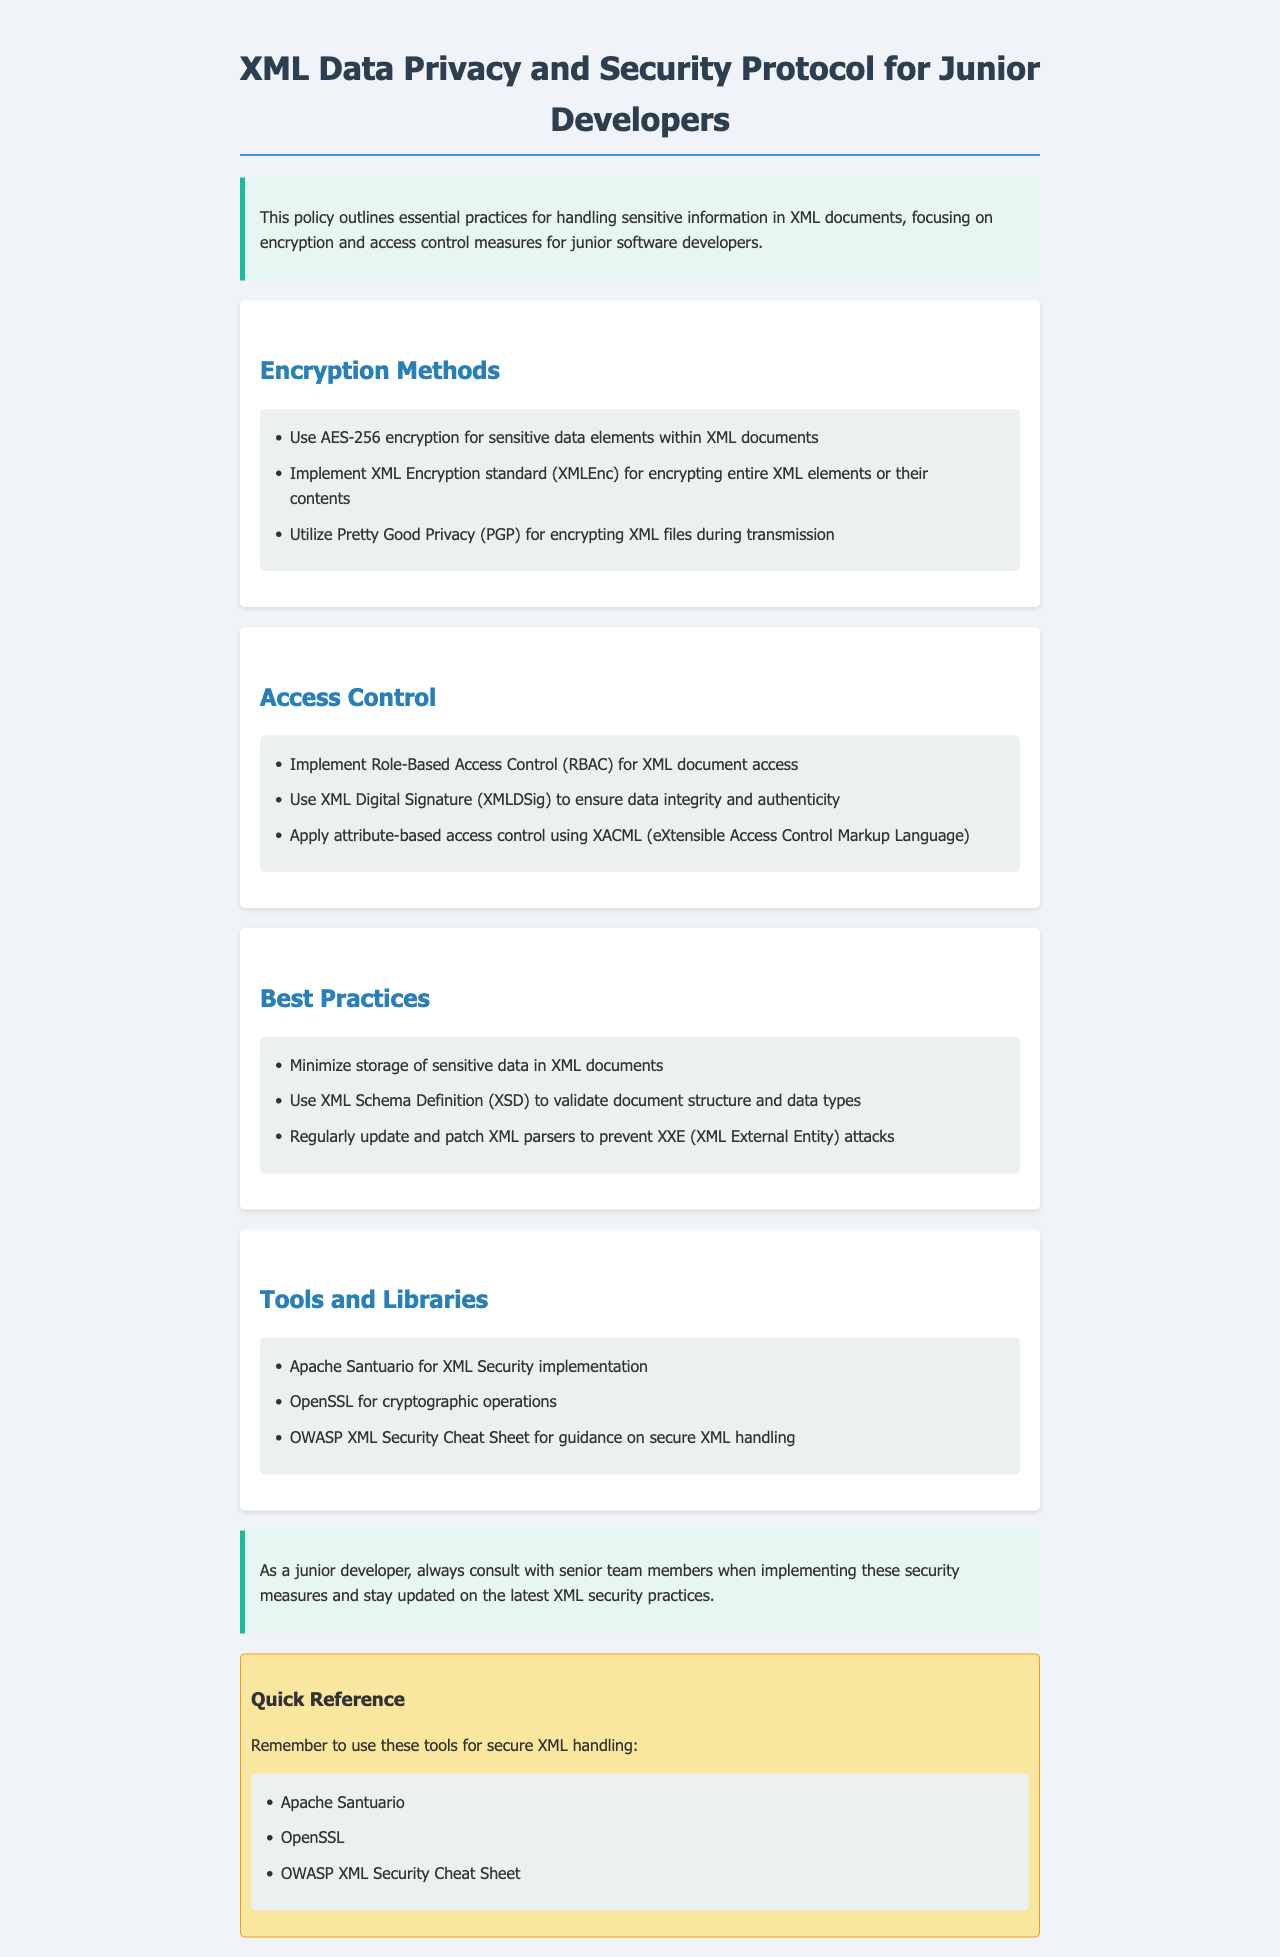What are the encryption methods mentioned? The document lists several encryption methods including AES-256, XML Encryption standard, and PGP.
Answer: AES-256, XML Encryption standard, PGP What does RBAC stand for in the context of access control? In the document, RBAC refers to Role-Based Access Control concerning XML document access.
Answer: Role-Based Access Control Which standard is used for encrypting entire XML elements? The document specifies the XML Encryption standard (XMLEnc) as the method for encrypting entire XML elements.
Answer: XML Encryption standard What should you do to ensure data integrity and authenticity? The document mentions the use of XML Digital Signature (XMLDSig) to ensure data integrity and authenticity.
Answer: XML Digital Signature How many tools are suggested for secure XML handling? The document lists three tools specifically aimed at secure XML handling.
Answer: Three What is the primary focus of this policy? The policy aims to outline practices for handling sensitive information, specifically regarding encryption and access control.
Answer: Encryption and access control Which library is recommended for cryptographic operations? The document includes OpenSSL as a recommended library for performing cryptographic operations.
Answer: OpenSSL What practice minimizes storage of sensitive data in XML documents? The document advises minimizing the storage of sensitive data as a best practice.
Answer: Minimize storage What is the significance of XML Schema Definition (XSD)? The document states XSD is used to validate document structure and data types.
Answer: Validate document structure and data types 